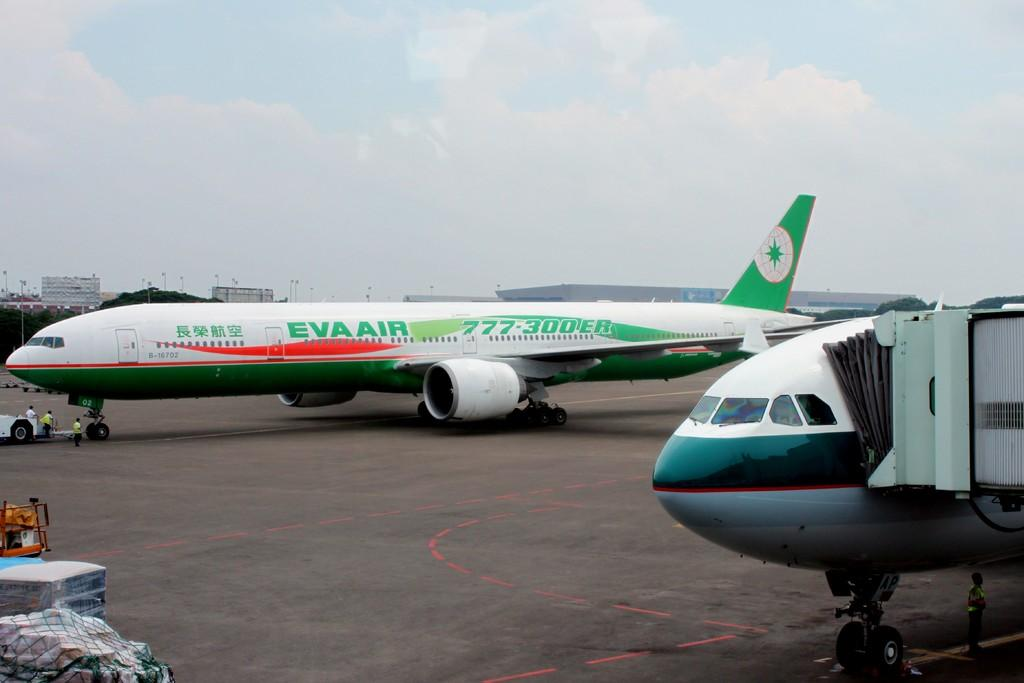<image>
Offer a succinct explanation of the picture presented. A Boeing 777 from Eva Air sits on the airport tarmac. 